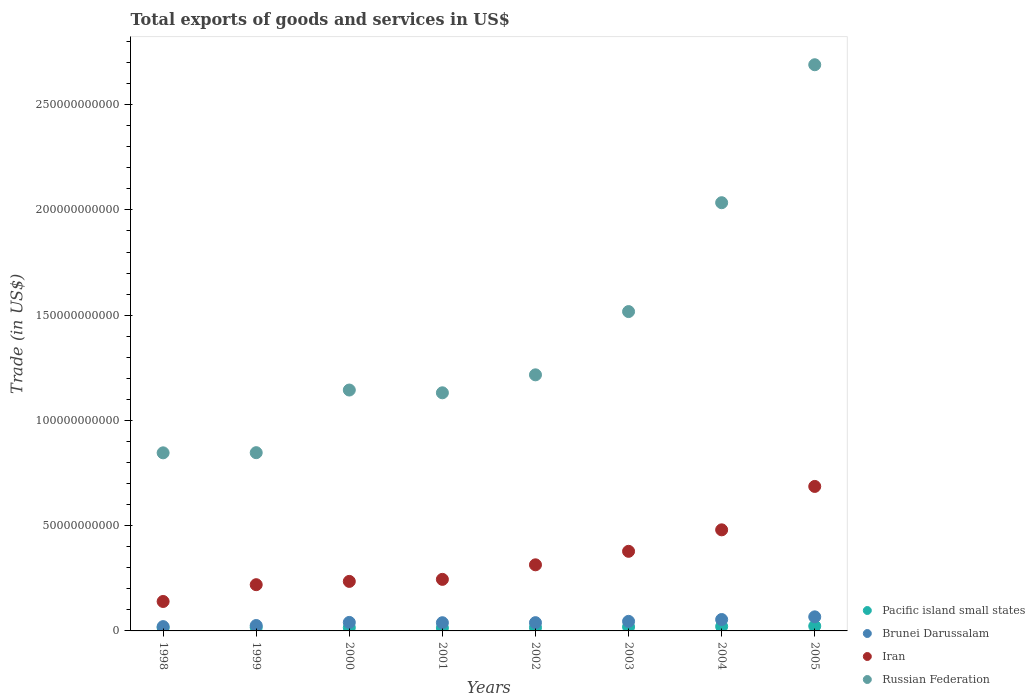How many different coloured dotlines are there?
Give a very brief answer. 4. Is the number of dotlines equal to the number of legend labels?
Offer a terse response. Yes. What is the total exports of goods and services in Russian Federation in 2004?
Give a very brief answer. 2.03e+11. Across all years, what is the maximum total exports of goods and services in Brunei Darussalam?
Provide a short and direct response. 6.69e+09. Across all years, what is the minimum total exports of goods and services in Brunei Darussalam?
Offer a very short reply. 2.04e+09. In which year was the total exports of goods and services in Iran maximum?
Provide a succinct answer. 2005. In which year was the total exports of goods and services in Iran minimum?
Provide a succinct answer. 1998. What is the total total exports of goods and services in Pacific island small states in the graph?
Ensure brevity in your answer.  1.40e+1. What is the difference between the total exports of goods and services in Brunei Darussalam in 1998 and that in 2003?
Keep it short and to the point. -2.50e+09. What is the difference between the total exports of goods and services in Brunei Darussalam in 2002 and the total exports of goods and services in Pacific island small states in 1999?
Give a very brief answer. 2.26e+09. What is the average total exports of goods and services in Russian Federation per year?
Make the answer very short. 1.43e+11. In the year 2000, what is the difference between the total exports of goods and services in Pacific island small states and total exports of goods and services in Russian Federation?
Offer a terse response. -1.13e+11. In how many years, is the total exports of goods and services in Pacific island small states greater than 120000000000 US$?
Provide a succinct answer. 0. What is the ratio of the total exports of goods and services in Russian Federation in 2001 to that in 2005?
Give a very brief answer. 0.42. What is the difference between the highest and the second highest total exports of goods and services in Russian Federation?
Your response must be concise. 6.55e+1. What is the difference between the highest and the lowest total exports of goods and services in Iran?
Provide a succinct answer. 5.46e+1. In how many years, is the total exports of goods and services in Iran greater than the average total exports of goods and services in Iran taken over all years?
Ensure brevity in your answer.  3. Is the sum of the total exports of goods and services in Brunei Darussalam in 1998 and 2002 greater than the maximum total exports of goods and services in Iran across all years?
Provide a succinct answer. No. Is it the case that in every year, the sum of the total exports of goods and services in Russian Federation and total exports of goods and services in Iran  is greater than the sum of total exports of goods and services in Pacific island small states and total exports of goods and services in Brunei Darussalam?
Make the answer very short. No. Is it the case that in every year, the sum of the total exports of goods and services in Pacific island small states and total exports of goods and services in Brunei Darussalam  is greater than the total exports of goods and services in Russian Federation?
Offer a terse response. No. How many dotlines are there?
Your answer should be very brief. 4. How many years are there in the graph?
Make the answer very short. 8. What is the difference between two consecutive major ticks on the Y-axis?
Keep it short and to the point. 5.00e+1. How are the legend labels stacked?
Your answer should be very brief. Vertical. What is the title of the graph?
Make the answer very short. Total exports of goods and services in US$. What is the label or title of the Y-axis?
Give a very brief answer. Trade (in US$). What is the Trade (in US$) of Pacific island small states in 1998?
Keep it short and to the point. 1.51e+09. What is the Trade (in US$) of Brunei Darussalam in 1998?
Keep it short and to the point. 2.04e+09. What is the Trade (in US$) in Iran in 1998?
Ensure brevity in your answer.  1.40e+1. What is the Trade (in US$) in Russian Federation in 1998?
Make the answer very short. 8.46e+1. What is the Trade (in US$) in Pacific island small states in 1999?
Your answer should be very brief. 1.67e+09. What is the Trade (in US$) in Brunei Darussalam in 1999?
Ensure brevity in your answer.  2.57e+09. What is the Trade (in US$) of Iran in 1999?
Ensure brevity in your answer.  2.20e+1. What is the Trade (in US$) in Russian Federation in 1999?
Your answer should be very brief. 8.47e+1. What is the Trade (in US$) in Pacific island small states in 2000?
Keep it short and to the point. 1.56e+09. What is the Trade (in US$) of Brunei Darussalam in 2000?
Offer a very short reply. 4.04e+09. What is the Trade (in US$) of Iran in 2000?
Ensure brevity in your answer.  2.35e+1. What is the Trade (in US$) of Russian Federation in 2000?
Offer a very short reply. 1.14e+11. What is the Trade (in US$) in Pacific island small states in 2001?
Offer a very short reply. 1.42e+09. What is the Trade (in US$) of Brunei Darussalam in 2001?
Offer a terse response. 3.89e+09. What is the Trade (in US$) in Iran in 2001?
Make the answer very short. 2.45e+1. What is the Trade (in US$) in Russian Federation in 2001?
Give a very brief answer. 1.13e+11. What is the Trade (in US$) of Pacific island small states in 2002?
Your response must be concise. 1.59e+09. What is the Trade (in US$) in Brunei Darussalam in 2002?
Your answer should be very brief. 3.92e+09. What is the Trade (in US$) of Iran in 2002?
Ensure brevity in your answer.  3.14e+1. What is the Trade (in US$) of Russian Federation in 2002?
Your answer should be compact. 1.22e+11. What is the Trade (in US$) of Pacific island small states in 2003?
Make the answer very short. 1.91e+09. What is the Trade (in US$) in Brunei Darussalam in 2003?
Ensure brevity in your answer.  4.54e+09. What is the Trade (in US$) of Iran in 2003?
Offer a very short reply. 3.78e+1. What is the Trade (in US$) in Russian Federation in 2003?
Your answer should be very brief. 1.52e+11. What is the Trade (in US$) of Pacific island small states in 2004?
Keep it short and to the point. 2.09e+09. What is the Trade (in US$) in Brunei Darussalam in 2004?
Provide a succinct answer. 5.42e+09. What is the Trade (in US$) of Iran in 2004?
Your answer should be very brief. 4.80e+1. What is the Trade (in US$) of Russian Federation in 2004?
Provide a succinct answer. 2.03e+11. What is the Trade (in US$) of Pacific island small states in 2005?
Your answer should be compact. 2.29e+09. What is the Trade (in US$) in Brunei Darussalam in 2005?
Your answer should be compact. 6.69e+09. What is the Trade (in US$) in Iran in 2005?
Keep it short and to the point. 6.86e+1. What is the Trade (in US$) of Russian Federation in 2005?
Offer a very short reply. 2.69e+11. Across all years, what is the maximum Trade (in US$) in Pacific island small states?
Offer a terse response. 2.29e+09. Across all years, what is the maximum Trade (in US$) in Brunei Darussalam?
Your answer should be very brief. 6.69e+09. Across all years, what is the maximum Trade (in US$) of Iran?
Make the answer very short. 6.86e+1. Across all years, what is the maximum Trade (in US$) of Russian Federation?
Give a very brief answer. 2.69e+11. Across all years, what is the minimum Trade (in US$) of Pacific island small states?
Your response must be concise. 1.42e+09. Across all years, what is the minimum Trade (in US$) of Brunei Darussalam?
Your answer should be very brief. 2.04e+09. Across all years, what is the minimum Trade (in US$) in Iran?
Provide a succinct answer. 1.40e+1. Across all years, what is the minimum Trade (in US$) in Russian Federation?
Give a very brief answer. 8.46e+1. What is the total Trade (in US$) in Pacific island small states in the graph?
Your answer should be compact. 1.40e+1. What is the total Trade (in US$) of Brunei Darussalam in the graph?
Provide a short and direct response. 3.31e+1. What is the total Trade (in US$) of Iran in the graph?
Give a very brief answer. 2.70e+11. What is the total Trade (in US$) of Russian Federation in the graph?
Provide a short and direct response. 1.14e+12. What is the difference between the Trade (in US$) in Pacific island small states in 1998 and that in 1999?
Offer a terse response. -1.59e+08. What is the difference between the Trade (in US$) of Brunei Darussalam in 1998 and that in 1999?
Offer a terse response. -5.23e+08. What is the difference between the Trade (in US$) in Iran in 1998 and that in 1999?
Keep it short and to the point. -7.98e+09. What is the difference between the Trade (in US$) in Russian Federation in 1998 and that in 1999?
Ensure brevity in your answer.  -7.54e+07. What is the difference between the Trade (in US$) in Pacific island small states in 1998 and that in 2000?
Your answer should be very brief. -5.57e+07. What is the difference between the Trade (in US$) in Brunei Darussalam in 1998 and that in 2000?
Your response must be concise. -2.00e+09. What is the difference between the Trade (in US$) in Iran in 1998 and that in 2000?
Give a very brief answer. -9.54e+09. What is the difference between the Trade (in US$) of Russian Federation in 1998 and that in 2000?
Give a very brief answer. -2.98e+1. What is the difference between the Trade (in US$) in Pacific island small states in 1998 and that in 2001?
Provide a succinct answer. 8.77e+07. What is the difference between the Trade (in US$) of Brunei Darussalam in 1998 and that in 2001?
Provide a succinct answer. -1.85e+09. What is the difference between the Trade (in US$) of Iran in 1998 and that in 2001?
Your answer should be compact. -1.05e+1. What is the difference between the Trade (in US$) in Russian Federation in 1998 and that in 2001?
Offer a very short reply. -2.85e+1. What is the difference between the Trade (in US$) in Pacific island small states in 1998 and that in 2002?
Make the answer very short. -8.04e+07. What is the difference between the Trade (in US$) of Brunei Darussalam in 1998 and that in 2002?
Offer a very short reply. -1.88e+09. What is the difference between the Trade (in US$) in Iran in 1998 and that in 2002?
Your answer should be compact. -1.74e+1. What is the difference between the Trade (in US$) of Russian Federation in 1998 and that in 2002?
Your response must be concise. -3.71e+1. What is the difference between the Trade (in US$) of Pacific island small states in 1998 and that in 2003?
Make the answer very short. -3.99e+08. What is the difference between the Trade (in US$) of Brunei Darussalam in 1998 and that in 2003?
Offer a very short reply. -2.50e+09. What is the difference between the Trade (in US$) of Iran in 1998 and that in 2003?
Make the answer very short. -2.38e+1. What is the difference between the Trade (in US$) in Russian Federation in 1998 and that in 2003?
Offer a terse response. -6.71e+1. What is the difference between the Trade (in US$) of Pacific island small states in 1998 and that in 2004?
Your response must be concise. -5.82e+08. What is the difference between the Trade (in US$) in Brunei Darussalam in 1998 and that in 2004?
Ensure brevity in your answer.  -3.37e+09. What is the difference between the Trade (in US$) of Iran in 1998 and that in 2004?
Offer a terse response. -3.40e+1. What is the difference between the Trade (in US$) in Russian Federation in 1998 and that in 2004?
Give a very brief answer. -1.19e+11. What is the difference between the Trade (in US$) in Pacific island small states in 1998 and that in 2005?
Make the answer very short. -7.88e+08. What is the difference between the Trade (in US$) in Brunei Darussalam in 1998 and that in 2005?
Offer a very short reply. -4.64e+09. What is the difference between the Trade (in US$) of Iran in 1998 and that in 2005?
Offer a very short reply. -5.46e+1. What is the difference between the Trade (in US$) in Russian Federation in 1998 and that in 2005?
Provide a succinct answer. -1.84e+11. What is the difference between the Trade (in US$) of Pacific island small states in 1999 and that in 2000?
Make the answer very short. 1.04e+08. What is the difference between the Trade (in US$) of Brunei Darussalam in 1999 and that in 2000?
Keep it short and to the point. -1.47e+09. What is the difference between the Trade (in US$) of Iran in 1999 and that in 2000?
Make the answer very short. -1.56e+09. What is the difference between the Trade (in US$) in Russian Federation in 1999 and that in 2000?
Offer a terse response. -2.98e+1. What is the difference between the Trade (in US$) in Pacific island small states in 1999 and that in 2001?
Your answer should be very brief. 2.47e+08. What is the difference between the Trade (in US$) in Brunei Darussalam in 1999 and that in 2001?
Ensure brevity in your answer.  -1.33e+09. What is the difference between the Trade (in US$) of Iran in 1999 and that in 2001?
Provide a succinct answer. -2.53e+09. What is the difference between the Trade (in US$) in Russian Federation in 1999 and that in 2001?
Offer a very short reply. -2.84e+1. What is the difference between the Trade (in US$) in Pacific island small states in 1999 and that in 2002?
Your response must be concise. 7.88e+07. What is the difference between the Trade (in US$) of Brunei Darussalam in 1999 and that in 2002?
Keep it short and to the point. -1.35e+09. What is the difference between the Trade (in US$) in Iran in 1999 and that in 2002?
Offer a terse response. -9.44e+09. What is the difference between the Trade (in US$) of Russian Federation in 1999 and that in 2002?
Make the answer very short. -3.70e+1. What is the difference between the Trade (in US$) of Pacific island small states in 1999 and that in 2003?
Your response must be concise. -2.40e+08. What is the difference between the Trade (in US$) in Brunei Darussalam in 1999 and that in 2003?
Offer a very short reply. -1.98e+09. What is the difference between the Trade (in US$) in Iran in 1999 and that in 2003?
Your response must be concise. -1.59e+1. What is the difference between the Trade (in US$) in Russian Federation in 1999 and that in 2003?
Keep it short and to the point. -6.70e+1. What is the difference between the Trade (in US$) of Pacific island small states in 1999 and that in 2004?
Give a very brief answer. -4.23e+08. What is the difference between the Trade (in US$) in Brunei Darussalam in 1999 and that in 2004?
Give a very brief answer. -2.85e+09. What is the difference between the Trade (in US$) in Iran in 1999 and that in 2004?
Provide a short and direct response. -2.61e+1. What is the difference between the Trade (in US$) of Russian Federation in 1999 and that in 2004?
Offer a terse response. -1.19e+11. What is the difference between the Trade (in US$) in Pacific island small states in 1999 and that in 2005?
Your response must be concise. -6.28e+08. What is the difference between the Trade (in US$) of Brunei Darussalam in 1999 and that in 2005?
Your answer should be very brief. -4.12e+09. What is the difference between the Trade (in US$) in Iran in 1999 and that in 2005?
Make the answer very short. -4.67e+1. What is the difference between the Trade (in US$) in Russian Federation in 1999 and that in 2005?
Your answer should be very brief. -1.84e+11. What is the difference between the Trade (in US$) in Pacific island small states in 2000 and that in 2001?
Your answer should be compact. 1.43e+08. What is the difference between the Trade (in US$) in Brunei Darussalam in 2000 and that in 2001?
Give a very brief answer. 1.48e+08. What is the difference between the Trade (in US$) in Iran in 2000 and that in 2001?
Make the answer very short. -9.66e+08. What is the difference between the Trade (in US$) in Russian Federation in 2000 and that in 2001?
Offer a very short reply. 1.31e+09. What is the difference between the Trade (in US$) in Pacific island small states in 2000 and that in 2002?
Your answer should be compact. -2.47e+07. What is the difference between the Trade (in US$) of Brunei Darussalam in 2000 and that in 2002?
Provide a short and direct response. 1.20e+08. What is the difference between the Trade (in US$) of Iran in 2000 and that in 2002?
Provide a succinct answer. -7.88e+09. What is the difference between the Trade (in US$) of Russian Federation in 2000 and that in 2002?
Keep it short and to the point. -7.22e+09. What is the difference between the Trade (in US$) of Pacific island small states in 2000 and that in 2003?
Ensure brevity in your answer.  -3.44e+08. What is the difference between the Trade (in US$) in Brunei Darussalam in 2000 and that in 2003?
Offer a terse response. -5.01e+08. What is the difference between the Trade (in US$) in Iran in 2000 and that in 2003?
Give a very brief answer. -1.43e+1. What is the difference between the Trade (in US$) in Russian Federation in 2000 and that in 2003?
Provide a short and direct response. -3.73e+1. What is the difference between the Trade (in US$) in Pacific island small states in 2000 and that in 2004?
Give a very brief answer. -5.27e+08. What is the difference between the Trade (in US$) in Brunei Darussalam in 2000 and that in 2004?
Keep it short and to the point. -1.37e+09. What is the difference between the Trade (in US$) of Iran in 2000 and that in 2004?
Make the answer very short. -2.45e+1. What is the difference between the Trade (in US$) of Russian Federation in 2000 and that in 2004?
Offer a terse response. -8.90e+1. What is the difference between the Trade (in US$) of Pacific island small states in 2000 and that in 2005?
Provide a short and direct response. -7.32e+08. What is the difference between the Trade (in US$) of Brunei Darussalam in 2000 and that in 2005?
Make the answer very short. -2.65e+09. What is the difference between the Trade (in US$) of Iran in 2000 and that in 2005?
Give a very brief answer. -4.51e+1. What is the difference between the Trade (in US$) of Russian Federation in 2000 and that in 2005?
Offer a terse response. -1.55e+11. What is the difference between the Trade (in US$) of Pacific island small states in 2001 and that in 2002?
Your response must be concise. -1.68e+08. What is the difference between the Trade (in US$) in Brunei Darussalam in 2001 and that in 2002?
Make the answer very short. -2.80e+07. What is the difference between the Trade (in US$) of Iran in 2001 and that in 2002?
Keep it short and to the point. -6.91e+09. What is the difference between the Trade (in US$) of Russian Federation in 2001 and that in 2002?
Offer a terse response. -8.53e+09. What is the difference between the Trade (in US$) in Pacific island small states in 2001 and that in 2003?
Offer a very short reply. -4.87e+08. What is the difference between the Trade (in US$) in Brunei Darussalam in 2001 and that in 2003?
Give a very brief answer. -6.49e+08. What is the difference between the Trade (in US$) in Iran in 2001 and that in 2003?
Give a very brief answer. -1.33e+1. What is the difference between the Trade (in US$) in Russian Federation in 2001 and that in 2003?
Your answer should be compact. -3.86e+1. What is the difference between the Trade (in US$) of Pacific island small states in 2001 and that in 2004?
Your answer should be compact. -6.70e+08. What is the difference between the Trade (in US$) of Brunei Darussalam in 2001 and that in 2004?
Provide a succinct answer. -1.52e+09. What is the difference between the Trade (in US$) of Iran in 2001 and that in 2004?
Ensure brevity in your answer.  -2.35e+1. What is the difference between the Trade (in US$) in Russian Federation in 2001 and that in 2004?
Make the answer very short. -9.03e+1. What is the difference between the Trade (in US$) of Pacific island small states in 2001 and that in 2005?
Give a very brief answer. -8.75e+08. What is the difference between the Trade (in US$) in Brunei Darussalam in 2001 and that in 2005?
Offer a very short reply. -2.79e+09. What is the difference between the Trade (in US$) in Iran in 2001 and that in 2005?
Your response must be concise. -4.41e+1. What is the difference between the Trade (in US$) of Russian Federation in 2001 and that in 2005?
Your answer should be compact. -1.56e+11. What is the difference between the Trade (in US$) of Pacific island small states in 2002 and that in 2003?
Keep it short and to the point. -3.19e+08. What is the difference between the Trade (in US$) of Brunei Darussalam in 2002 and that in 2003?
Keep it short and to the point. -6.21e+08. What is the difference between the Trade (in US$) of Iran in 2002 and that in 2003?
Offer a very short reply. -6.41e+09. What is the difference between the Trade (in US$) of Russian Federation in 2002 and that in 2003?
Keep it short and to the point. -3.00e+1. What is the difference between the Trade (in US$) in Pacific island small states in 2002 and that in 2004?
Offer a very short reply. -5.02e+08. What is the difference between the Trade (in US$) of Brunei Darussalam in 2002 and that in 2004?
Make the answer very short. -1.49e+09. What is the difference between the Trade (in US$) in Iran in 2002 and that in 2004?
Ensure brevity in your answer.  -1.66e+1. What is the difference between the Trade (in US$) in Russian Federation in 2002 and that in 2004?
Your answer should be very brief. -8.18e+1. What is the difference between the Trade (in US$) in Pacific island small states in 2002 and that in 2005?
Give a very brief answer. -7.07e+08. What is the difference between the Trade (in US$) of Brunei Darussalam in 2002 and that in 2005?
Your answer should be compact. -2.77e+09. What is the difference between the Trade (in US$) in Iran in 2002 and that in 2005?
Ensure brevity in your answer.  -3.72e+1. What is the difference between the Trade (in US$) of Russian Federation in 2002 and that in 2005?
Offer a very short reply. -1.47e+11. What is the difference between the Trade (in US$) of Pacific island small states in 2003 and that in 2004?
Your answer should be compact. -1.83e+08. What is the difference between the Trade (in US$) in Brunei Darussalam in 2003 and that in 2004?
Your answer should be very brief. -8.73e+08. What is the difference between the Trade (in US$) in Iran in 2003 and that in 2004?
Make the answer very short. -1.02e+1. What is the difference between the Trade (in US$) of Russian Federation in 2003 and that in 2004?
Give a very brief answer. -5.17e+1. What is the difference between the Trade (in US$) of Pacific island small states in 2003 and that in 2005?
Your answer should be compact. -3.88e+08. What is the difference between the Trade (in US$) in Brunei Darussalam in 2003 and that in 2005?
Your response must be concise. -2.14e+09. What is the difference between the Trade (in US$) of Iran in 2003 and that in 2005?
Offer a very short reply. -3.08e+1. What is the difference between the Trade (in US$) of Russian Federation in 2003 and that in 2005?
Make the answer very short. -1.17e+11. What is the difference between the Trade (in US$) of Pacific island small states in 2004 and that in 2005?
Keep it short and to the point. -2.05e+08. What is the difference between the Trade (in US$) in Brunei Darussalam in 2004 and that in 2005?
Your answer should be compact. -1.27e+09. What is the difference between the Trade (in US$) of Iran in 2004 and that in 2005?
Offer a very short reply. -2.06e+1. What is the difference between the Trade (in US$) in Russian Federation in 2004 and that in 2005?
Your answer should be compact. -6.55e+1. What is the difference between the Trade (in US$) in Pacific island small states in 1998 and the Trade (in US$) in Brunei Darussalam in 1999?
Your answer should be compact. -1.06e+09. What is the difference between the Trade (in US$) of Pacific island small states in 1998 and the Trade (in US$) of Iran in 1999?
Give a very brief answer. -2.05e+1. What is the difference between the Trade (in US$) of Pacific island small states in 1998 and the Trade (in US$) of Russian Federation in 1999?
Offer a terse response. -8.32e+1. What is the difference between the Trade (in US$) in Brunei Darussalam in 1998 and the Trade (in US$) in Iran in 1999?
Provide a short and direct response. -1.99e+1. What is the difference between the Trade (in US$) in Brunei Darussalam in 1998 and the Trade (in US$) in Russian Federation in 1999?
Make the answer very short. -8.26e+1. What is the difference between the Trade (in US$) in Iran in 1998 and the Trade (in US$) in Russian Federation in 1999?
Make the answer very short. -7.07e+1. What is the difference between the Trade (in US$) in Pacific island small states in 1998 and the Trade (in US$) in Brunei Darussalam in 2000?
Ensure brevity in your answer.  -2.53e+09. What is the difference between the Trade (in US$) of Pacific island small states in 1998 and the Trade (in US$) of Iran in 2000?
Ensure brevity in your answer.  -2.20e+1. What is the difference between the Trade (in US$) of Pacific island small states in 1998 and the Trade (in US$) of Russian Federation in 2000?
Offer a very short reply. -1.13e+11. What is the difference between the Trade (in US$) of Brunei Darussalam in 1998 and the Trade (in US$) of Iran in 2000?
Your answer should be compact. -2.15e+1. What is the difference between the Trade (in US$) of Brunei Darussalam in 1998 and the Trade (in US$) of Russian Federation in 2000?
Offer a terse response. -1.12e+11. What is the difference between the Trade (in US$) in Iran in 1998 and the Trade (in US$) in Russian Federation in 2000?
Provide a succinct answer. -1.00e+11. What is the difference between the Trade (in US$) in Pacific island small states in 1998 and the Trade (in US$) in Brunei Darussalam in 2001?
Your answer should be compact. -2.39e+09. What is the difference between the Trade (in US$) in Pacific island small states in 1998 and the Trade (in US$) in Iran in 2001?
Offer a terse response. -2.30e+1. What is the difference between the Trade (in US$) in Pacific island small states in 1998 and the Trade (in US$) in Russian Federation in 2001?
Your response must be concise. -1.12e+11. What is the difference between the Trade (in US$) in Brunei Darussalam in 1998 and the Trade (in US$) in Iran in 2001?
Make the answer very short. -2.24e+1. What is the difference between the Trade (in US$) in Brunei Darussalam in 1998 and the Trade (in US$) in Russian Federation in 2001?
Your answer should be very brief. -1.11e+11. What is the difference between the Trade (in US$) in Iran in 1998 and the Trade (in US$) in Russian Federation in 2001?
Offer a very short reply. -9.91e+1. What is the difference between the Trade (in US$) in Pacific island small states in 1998 and the Trade (in US$) in Brunei Darussalam in 2002?
Offer a very short reply. -2.42e+09. What is the difference between the Trade (in US$) of Pacific island small states in 1998 and the Trade (in US$) of Iran in 2002?
Provide a short and direct response. -2.99e+1. What is the difference between the Trade (in US$) in Pacific island small states in 1998 and the Trade (in US$) in Russian Federation in 2002?
Make the answer very short. -1.20e+11. What is the difference between the Trade (in US$) of Brunei Darussalam in 1998 and the Trade (in US$) of Iran in 2002?
Make the answer very short. -2.94e+1. What is the difference between the Trade (in US$) in Brunei Darussalam in 1998 and the Trade (in US$) in Russian Federation in 2002?
Ensure brevity in your answer.  -1.20e+11. What is the difference between the Trade (in US$) in Iran in 1998 and the Trade (in US$) in Russian Federation in 2002?
Your response must be concise. -1.08e+11. What is the difference between the Trade (in US$) in Pacific island small states in 1998 and the Trade (in US$) in Brunei Darussalam in 2003?
Your answer should be very brief. -3.04e+09. What is the difference between the Trade (in US$) of Pacific island small states in 1998 and the Trade (in US$) of Iran in 2003?
Make the answer very short. -3.63e+1. What is the difference between the Trade (in US$) of Pacific island small states in 1998 and the Trade (in US$) of Russian Federation in 2003?
Give a very brief answer. -1.50e+11. What is the difference between the Trade (in US$) in Brunei Darussalam in 1998 and the Trade (in US$) in Iran in 2003?
Give a very brief answer. -3.58e+1. What is the difference between the Trade (in US$) in Brunei Darussalam in 1998 and the Trade (in US$) in Russian Federation in 2003?
Your answer should be compact. -1.50e+11. What is the difference between the Trade (in US$) in Iran in 1998 and the Trade (in US$) in Russian Federation in 2003?
Give a very brief answer. -1.38e+11. What is the difference between the Trade (in US$) of Pacific island small states in 1998 and the Trade (in US$) of Brunei Darussalam in 2004?
Offer a very short reply. -3.91e+09. What is the difference between the Trade (in US$) in Pacific island small states in 1998 and the Trade (in US$) in Iran in 2004?
Provide a short and direct response. -4.65e+1. What is the difference between the Trade (in US$) of Pacific island small states in 1998 and the Trade (in US$) of Russian Federation in 2004?
Ensure brevity in your answer.  -2.02e+11. What is the difference between the Trade (in US$) of Brunei Darussalam in 1998 and the Trade (in US$) of Iran in 2004?
Offer a very short reply. -4.60e+1. What is the difference between the Trade (in US$) of Brunei Darussalam in 1998 and the Trade (in US$) of Russian Federation in 2004?
Your answer should be very brief. -2.01e+11. What is the difference between the Trade (in US$) of Iran in 1998 and the Trade (in US$) of Russian Federation in 2004?
Keep it short and to the point. -1.89e+11. What is the difference between the Trade (in US$) in Pacific island small states in 1998 and the Trade (in US$) in Brunei Darussalam in 2005?
Provide a succinct answer. -5.18e+09. What is the difference between the Trade (in US$) of Pacific island small states in 1998 and the Trade (in US$) of Iran in 2005?
Your response must be concise. -6.71e+1. What is the difference between the Trade (in US$) of Pacific island small states in 1998 and the Trade (in US$) of Russian Federation in 2005?
Provide a succinct answer. -2.67e+11. What is the difference between the Trade (in US$) in Brunei Darussalam in 1998 and the Trade (in US$) in Iran in 2005?
Your answer should be compact. -6.66e+1. What is the difference between the Trade (in US$) of Brunei Darussalam in 1998 and the Trade (in US$) of Russian Federation in 2005?
Make the answer very short. -2.67e+11. What is the difference between the Trade (in US$) of Iran in 1998 and the Trade (in US$) of Russian Federation in 2005?
Provide a succinct answer. -2.55e+11. What is the difference between the Trade (in US$) in Pacific island small states in 1999 and the Trade (in US$) in Brunei Darussalam in 2000?
Give a very brief answer. -2.38e+09. What is the difference between the Trade (in US$) in Pacific island small states in 1999 and the Trade (in US$) in Iran in 2000?
Your answer should be compact. -2.19e+1. What is the difference between the Trade (in US$) in Pacific island small states in 1999 and the Trade (in US$) in Russian Federation in 2000?
Keep it short and to the point. -1.13e+11. What is the difference between the Trade (in US$) in Brunei Darussalam in 1999 and the Trade (in US$) in Iran in 2000?
Keep it short and to the point. -2.10e+1. What is the difference between the Trade (in US$) in Brunei Darussalam in 1999 and the Trade (in US$) in Russian Federation in 2000?
Give a very brief answer. -1.12e+11. What is the difference between the Trade (in US$) in Iran in 1999 and the Trade (in US$) in Russian Federation in 2000?
Keep it short and to the point. -9.25e+1. What is the difference between the Trade (in US$) in Pacific island small states in 1999 and the Trade (in US$) in Brunei Darussalam in 2001?
Offer a terse response. -2.23e+09. What is the difference between the Trade (in US$) of Pacific island small states in 1999 and the Trade (in US$) of Iran in 2001?
Provide a succinct answer. -2.28e+1. What is the difference between the Trade (in US$) in Pacific island small states in 1999 and the Trade (in US$) in Russian Federation in 2001?
Offer a very short reply. -1.11e+11. What is the difference between the Trade (in US$) of Brunei Darussalam in 1999 and the Trade (in US$) of Iran in 2001?
Provide a succinct answer. -2.19e+1. What is the difference between the Trade (in US$) of Brunei Darussalam in 1999 and the Trade (in US$) of Russian Federation in 2001?
Provide a short and direct response. -1.11e+11. What is the difference between the Trade (in US$) in Iran in 1999 and the Trade (in US$) in Russian Federation in 2001?
Make the answer very short. -9.12e+1. What is the difference between the Trade (in US$) in Pacific island small states in 1999 and the Trade (in US$) in Brunei Darussalam in 2002?
Provide a short and direct response. -2.26e+09. What is the difference between the Trade (in US$) of Pacific island small states in 1999 and the Trade (in US$) of Iran in 2002?
Keep it short and to the point. -2.97e+1. What is the difference between the Trade (in US$) of Pacific island small states in 1999 and the Trade (in US$) of Russian Federation in 2002?
Your answer should be compact. -1.20e+11. What is the difference between the Trade (in US$) in Brunei Darussalam in 1999 and the Trade (in US$) in Iran in 2002?
Keep it short and to the point. -2.88e+1. What is the difference between the Trade (in US$) of Brunei Darussalam in 1999 and the Trade (in US$) of Russian Federation in 2002?
Your answer should be compact. -1.19e+11. What is the difference between the Trade (in US$) of Iran in 1999 and the Trade (in US$) of Russian Federation in 2002?
Provide a short and direct response. -9.97e+1. What is the difference between the Trade (in US$) in Pacific island small states in 1999 and the Trade (in US$) in Brunei Darussalam in 2003?
Offer a terse response. -2.88e+09. What is the difference between the Trade (in US$) of Pacific island small states in 1999 and the Trade (in US$) of Iran in 2003?
Offer a terse response. -3.61e+1. What is the difference between the Trade (in US$) in Pacific island small states in 1999 and the Trade (in US$) in Russian Federation in 2003?
Ensure brevity in your answer.  -1.50e+11. What is the difference between the Trade (in US$) in Brunei Darussalam in 1999 and the Trade (in US$) in Iran in 2003?
Your answer should be compact. -3.52e+1. What is the difference between the Trade (in US$) in Brunei Darussalam in 1999 and the Trade (in US$) in Russian Federation in 2003?
Provide a short and direct response. -1.49e+11. What is the difference between the Trade (in US$) of Iran in 1999 and the Trade (in US$) of Russian Federation in 2003?
Ensure brevity in your answer.  -1.30e+11. What is the difference between the Trade (in US$) in Pacific island small states in 1999 and the Trade (in US$) in Brunei Darussalam in 2004?
Your response must be concise. -3.75e+09. What is the difference between the Trade (in US$) in Pacific island small states in 1999 and the Trade (in US$) in Iran in 2004?
Provide a succinct answer. -4.64e+1. What is the difference between the Trade (in US$) of Pacific island small states in 1999 and the Trade (in US$) of Russian Federation in 2004?
Give a very brief answer. -2.02e+11. What is the difference between the Trade (in US$) in Brunei Darussalam in 1999 and the Trade (in US$) in Iran in 2004?
Offer a terse response. -4.55e+1. What is the difference between the Trade (in US$) of Brunei Darussalam in 1999 and the Trade (in US$) of Russian Federation in 2004?
Offer a terse response. -2.01e+11. What is the difference between the Trade (in US$) of Iran in 1999 and the Trade (in US$) of Russian Federation in 2004?
Offer a terse response. -1.81e+11. What is the difference between the Trade (in US$) of Pacific island small states in 1999 and the Trade (in US$) of Brunei Darussalam in 2005?
Your answer should be compact. -5.02e+09. What is the difference between the Trade (in US$) of Pacific island small states in 1999 and the Trade (in US$) of Iran in 2005?
Keep it short and to the point. -6.70e+1. What is the difference between the Trade (in US$) of Pacific island small states in 1999 and the Trade (in US$) of Russian Federation in 2005?
Your response must be concise. -2.67e+11. What is the difference between the Trade (in US$) of Brunei Darussalam in 1999 and the Trade (in US$) of Iran in 2005?
Provide a succinct answer. -6.61e+1. What is the difference between the Trade (in US$) in Brunei Darussalam in 1999 and the Trade (in US$) in Russian Federation in 2005?
Give a very brief answer. -2.66e+11. What is the difference between the Trade (in US$) in Iran in 1999 and the Trade (in US$) in Russian Federation in 2005?
Keep it short and to the point. -2.47e+11. What is the difference between the Trade (in US$) in Pacific island small states in 2000 and the Trade (in US$) in Brunei Darussalam in 2001?
Your answer should be compact. -2.33e+09. What is the difference between the Trade (in US$) of Pacific island small states in 2000 and the Trade (in US$) of Iran in 2001?
Your response must be concise. -2.29e+1. What is the difference between the Trade (in US$) of Pacific island small states in 2000 and the Trade (in US$) of Russian Federation in 2001?
Keep it short and to the point. -1.12e+11. What is the difference between the Trade (in US$) of Brunei Darussalam in 2000 and the Trade (in US$) of Iran in 2001?
Make the answer very short. -2.04e+1. What is the difference between the Trade (in US$) in Brunei Darussalam in 2000 and the Trade (in US$) in Russian Federation in 2001?
Ensure brevity in your answer.  -1.09e+11. What is the difference between the Trade (in US$) of Iran in 2000 and the Trade (in US$) of Russian Federation in 2001?
Make the answer very short. -8.96e+1. What is the difference between the Trade (in US$) of Pacific island small states in 2000 and the Trade (in US$) of Brunei Darussalam in 2002?
Your answer should be very brief. -2.36e+09. What is the difference between the Trade (in US$) of Pacific island small states in 2000 and the Trade (in US$) of Iran in 2002?
Offer a very short reply. -2.98e+1. What is the difference between the Trade (in US$) of Pacific island small states in 2000 and the Trade (in US$) of Russian Federation in 2002?
Your answer should be very brief. -1.20e+11. What is the difference between the Trade (in US$) in Brunei Darussalam in 2000 and the Trade (in US$) in Iran in 2002?
Provide a short and direct response. -2.74e+1. What is the difference between the Trade (in US$) of Brunei Darussalam in 2000 and the Trade (in US$) of Russian Federation in 2002?
Provide a short and direct response. -1.18e+11. What is the difference between the Trade (in US$) in Iran in 2000 and the Trade (in US$) in Russian Federation in 2002?
Your response must be concise. -9.81e+1. What is the difference between the Trade (in US$) of Pacific island small states in 2000 and the Trade (in US$) of Brunei Darussalam in 2003?
Offer a very short reply. -2.98e+09. What is the difference between the Trade (in US$) of Pacific island small states in 2000 and the Trade (in US$) of Iran in 2003?
Ensure brevity in your answer.  -3.63e+1. What is the difference between the Trade (in US$) in Pacific island small states in 2000 and the Trade (in US$) in Russian Federation in 2003?
Make the answer very short. -1.50e+11. What is the difference between the Trade (in US$) of Brunei Darussalam in 2000 and the Trade (in US$) of Iran in 2003?
Offer a terse response. -3.38e+1. What is the difference between the Trade (in US$) of Brunei Darussalam in 2000 and the Trade (in US$) of Russian Federation in 2003?
Your response must be concise. -1.48e+11. What is the difference between the Trade (in US$) in Iran in 2000 and the Trade (in US$) in Russian Federation in 2003?
Give a very brief answer. -1.28e+11. What is the difference between the Trade (in US$) in Pacific island small states in 2000 and the Trade (in US$) in Brunei Darussalam in 2004?
Offer a very short reply. -3.85e+09. What is the difference between the Trade (in US$) in Pacific island small states in 2000 and the Trade (in US$) in Iran in 2004?
Keep it short and to the point. -4.65e+1. What is the difference between the Trade (in US$) in Pacific island small states in 2000 and the Trade (in US$) in Russian Federation in 2004?
Make the answer very short. -2.02e+11. What is the difference between the Trade (in US$) in Brunei Darussalam in 2000 and the Trade (in US$) in Iran in 2004?
Offer a very short reply. -4.40e+1. What is the difference between the Trade (in US$) in Brunei Darussalam in 2000 and the Trade (in US$) in Russian Federation in 2004?
Your answer should be compact. -1.99e+11. What is the difference between the Trade (in US$) in Iran in 2000 and the Trade (in US$) in Russian Federation in 2004?
Give a very brief answer. -1.80e+11. What is the difference between the Trade (in US$) in Pacific island small states in 2000 and the Trade (in US$) in Brunei Darussalam in 2005?
Give a very brief answer. -5.13e+09. What is the difference between the Trade (in US$) in Pacific island small states in 2000 and the Trade (in US$) in Iran in 2005?
Your answer should be compact. -6.71e+1. What is the difference between the Trade (in US$) in Pacific island small states in 2000 and the Trade (in US$) in Russian Federation in 2005?
Offer a very short reply. -2.67e+11. What is the difference between the Trade (in US$) in Brunei Darussalam in 2000 and the Trade (in US$) in Iran in 2005?
Make the answer very short. -6.46e+1. What is the difference between the Trade (in US$) of Brunei Darussalam in 2000 and the Trade (in US$) of Russian Federation in 2005?
Offer a terse response. -2.65e+11. What is the difference between the Trade (in US$) of Iran in 2000 and the Trade (in US$) of Russian Federation in 2005?
Your answer should be compact. -2.45e+11. What is the difference between the Trade (in US$) of Pacific island small states in 2001 and the Trade (in US$) of Brunei Darussalam in 2002?
Offer a terse response. -2.50e+09. What is the difference between the Trade (in US$) of Pacific island small states in 2001 and the Trade (in US$) of Iran in 2002?
Keep it short and to the point. -3.00e+1. What is the difference between the Trade (in US$) of Pacific island small states in 2001 and the Trade (in US$) of Russian Federation in 2002?
Give a very brief answer. -1.20e+11. What is the difference between the Trade (in US$) in Brunei Darussalam in 2001 and the Trade (in US$) in Iran in 2002?
Ensure brevity in your answer.  -2.75e+1. What is the difference between the Trade (in US$) in Brunei Darussalam in 2001 and the Trade (in US$) in Russian Federation in 2002?
Your answer should be compact. -1.18e+11. What is the difference between the Trade (in US$) of Iran in 2001 and the Trade (in US$) of Russian Federation in 2002?
Keep it short and to the point. -9.72e+1. What is the difference between the Trade (in US$) of Pacific island small states in 2001 and the Trade (in US$) of Brunei Darussalam in 2003?
Give a very brief answer. -3.12e+09. What is the difference between the Trade (in US$) in Pacific island small states in 2001 and the Trade (in US$) in Iran in 2003?
Give a very brief answer. -3.64e+1. What is the difference between the Trade (in US$) of Pacific island small states in 2001 and the Trade (in US$) of Russian Federation in 2003?
Your answer should be compact. -1.50e+11. What is the difference between the Trade (in US$) of Brunei Darussalam in 2001 and the Trade (in US$) of Iran in 2003?
Make the answer very short. -3.39e+1. What is the difference between the Trade (in US$) of Brunei Darussalam in 2001 and the Trade (in US$) of Russian Federation in 2003?
Give a very brief answer. -1.48e+11. What is the difference between the Trade (in US$) of Iran in 2001 and the Trade (in US$) of Russian Federation in 2003?
Offer a terse response. -1.27e+11. What is the difference between the Trade (in US$) of Pacific island small states in 2001 and the Trade (in US$) of Brunei Darussalam in 2004?
Make the answer very short. -4.00e+09. What is the difference between the Trade (in US$) of Pacific island small states in 2001 and the Trade (in US$) of Iran in 2004?
Provide a short and direct response. -4.66e+1. What is the difference between the Trade (in US$) of Pacific island small states in 2001 and the Trade (in US$) of Russian Federation in 2004?
Provide a succinct answer. -2.02e+11. What is the difference between the Trade (in US$) in Brunei Darussalam in 2001 and the Trade (in US$) in Iran in 2004?
Make the answer very short. -4.41e+1. What is the difference between the Trade (in US$) of Brunei Darussalam in 2001 and the Trade (in US$) of Russian Federation in 2004?
Ensure brevity in your answer.  -2.00e+11. What is the difference between the Trade (in US$) of Iran in 2001 and the Trade (in US$) of Russian Federation in 2004?
Ensure brevity in your answer.  -1.79e+11. What is the difference between the Trade (in US$) in Pacific island small states in 2001 and the Trade (in US$) in Brunei Darussalam in 2005?
Keep it short and to the point. -5.27e+09. What is the difference between the Trade (in US$) of Pacific island small states in 2001 and the Trade (in US$) of Iran in 2005?
Ensure brevity in your answer.  -6.72e+1. What is the difference between the Trade (in US$) in Pacific island small states in 2001 and the Trade (in US$) in Russian Federation in 2005?
Keep it short and to the point. -2.68e+11. What is the difference between the Trade (in US$) of Brunei Darussalam in 2001 and the Trade (in US$) of Iran in 2005?
Keep it short and to the point. -6.47e+1. What is the difference between the Trade (in US$) in Brunei Darussalam in 2001 and the Trade (in US$) in Russian Federation in 2005?
Keep it short and to the point. -2.65e+11. What is the difference between the Trade (in US$) in Iran in 2001 and the Trade (in US$) in Russian Federation in 2005?
Offer a terse response. -2.44e+11. What is the difference between the Trade (in US$) of Pacific island small states in 2002 and the Trade (in US$) of Brunei Darussalam in 2003?
Your response must be concise. -2.96e+09. What is the difference between the Trade (in US$) of Pacific island small states in 2002 and the Trade (in US$) of Iran in 2003?
Provide a succinct answer. -3.62e+1. What is the difference between the Trade (in US$) of Pacific island small states in 2002 and the Trade (in US$) of Russian Federation in 2003?
Give a very brief answer. -1.50e+11. What is the difference between the Trade (in US$) of Brunei Darussalam in 2002 and the Trade (in US$) of Iran in 2003?
Your response must be concise. -3.39e+1. What is the difference between the Trade (in US$) in Brunei Darussalam in 2002 and the Trade (in US$) in Russian Federation in 2003?
Give a very brief answer. -1.48e+11. What is the difference between the Trade (in US$) of Iran in 2002 and the Trade (in US$) of Russian Federation in 2003?
Provide a short and direct response. -1.20e+11. What is the difference between the Trade (in US$) in Pacific island small states in 2002 and the Trade (in US$) in Brunei Darussalam in 2004?
Provide a short and direct response. -3.83e+09. What is the difference between the Trade (in US$) of Pacific island small states in 2002 and the Trade (in US$) of Iran in 2004?
Keep it short and to the point. -4.64e+1. What is the difference between the Trade (in US$) of Pacific island small states in 2002 and the Trade (in US$) of Russian Federation in 2004?
Make the answer very short. -2.02e+11. What is the difference between the Trade (in US$) in Brunei Darussalam in 2002 and the Trade (in US$) in Iran in 2004?
Offer a very short reply. -4.41e+1. What is the difference between the Trade (in US$) of Brunei Darussalam in 2002 and the Trade (in US$) of Russian Federation in 2004?
Your answer should be very brief. -1.99e+11. What is the difference between the Trade (in US$) of Iran in 2002 and the Trade (in US$) of Russian Federation in 2004?
Give a very brief answer. -1.72e+11. What is the difference between the Trade (in US$) of Pacific island small states in 2002 and the Trade (in US$) of Brunei Darussalam in 2005?
Give a very brief answer. -5.10e+09. What is the difference between the Trade (in US$) of Pacific island small states in 2002 and the Trade (in US$) of Iran in 2005?
Your answer should be compact. -6.70e+1. What is the difference between the Trade (in US$) in Pacific island small states in 2002 and the Trade (in US$) in Russian Federation in 2005?
Make the answer very short. -2.67e+11. What is the difference between the Trade (in US$) in Brunei Darussalam in 2002 and the Trade (in US$) in Iran in 2005?
Your answer should be very brief. -6.47e+1. What is the difference between the Trade (in US$) in Brunei Darussalam in 2002 and the Trade (in US$) in Russian Federation in 2005?
Your response must be concise. -2.65e+11. What is the difference between the Trade (in US$) of Iran in 2002 and the Trade (in US$) of Russian Federation in 2005?
Provide a short and direct response. -2.38e+11. What is the difference between the Trade (in US$) of Pacific island small states in 2003 and the Trade (in US$) of Brunei Darussalam in 2004?
Your answer should be very brief. -3.51e+09. What is the difference between the Trade (in US$) in Pacific island small states in 2003 and the Trade (in US$) in Iran in 2004?
Give a very brief answer. -4.61e+1. What is the difference between the Trade (in US$) in Pacific island small states in 2003 and the Trade (in US$) in Russian Federation in 2004?
Provide a short and direct response. -2.02e+11. What is the difference between the Trade (in US$) of Brunei Darussalam in 2003 and the Trade (in US$) of Iran in 2004?
Your answer should be very brief. -4.35e+1. What is the difference between the Trade (in US$) of Brunei Darussalam in 2003 and the Trade (in US$) of Russian Federation in 2004?
Give a very brief answer. -1.99e+11. What is the difference between the Trade (in US$) of Iran in 2003 and the Trade (in US$) of Russian Federation in 2004?
Your answer should be very brief. -1.66e+11. What is the difference between the Trade (in US$) of Pacific island small states in 2003 and the Trade (in US$) of Brunei Darussalam in 2005?
Your answer should be very brief. -4.78e+09. What is the difference between the Trade (in US$) in Pacific island small states in 2003 and the Trade (in US$) in Iran in 2005?
Your response must be concise. -6.67e+1. What is the difference between the Trade (in US$) in Pacific island small states in 2003 and the Trade (in US$) in Russian Federation in 2005?
Your response must be concise. -2.67e+11. What is the difference between the Trade (in US$) of Brunei Darussalam in 2003 and the Trade (in US$) of Iran in 2005?
Keep it short and to the point. -6.41e+1. What is the difference between the Trade (in US$) in Brunei Darussalam in 2003 and the Trade (in US$) in Russian Federation in 2005?
Your answer should be very brief. -2.64e+11. What is the difference between the Trade (in US$) of Iran in 2003 and the Trade (in US$) of Russian Federation in 2005?
Keep it short and to the point. -2.31e+11. What is the difference between the Trade (in US$) in Pacific island small states in 2004 and the Trade (in US$) in Brunei Darussalam in 2005?
Your answer should be very brief. -4.60e+09. What is the difference between the Trade (in US$) of Pacific island small states in 2004 and the Trade (in US$) of Iran in 2005?
Your answer should be compact. -6.65e+1. What is the difference between the Trade (in US$) of Pacific island small states in 2004 and the Trade (in US$) of Russian Federation in 2005?
Provide a short and direct response. -2.67e+11. What is the difference between the Trade (in US$) of Brunei Darussalam in 2004 and the Trade (in US$) of Iran in 2005?
Make the answer very short. -6.32e+1. What is the difference between the Trade (in US$) of Brunei Darussalam in 2004 and the Trade (in US$) of Russian Federation in 2005?
Offer a very short reply. -2.64e+11. What is the difference between the Trade (in US$) in Iran in 2004 and the Trade (in US$) in Russian Federation in 2005?
Make the answer very short. -2.21e+11. What is the average Trade (in US$) in Pacific island small states per year?
Your response must be concise. 1.75e+09. What is the average Trade (in US$) of Brunei Darussalam per year?
Offer a terse response. 4.14e+09. What is the average Trade (in US$) of Iran per year?
Give a very brief answer. 3.37e+1. What is the average Trade (in US$) in Russian Federation per year?
Give a very brief answer. 1.43e+11. In the year 1998, what is the difference between the Trade (in US$) of Pacific island small states and Trade (in US$) of Brunei Darussalam?
Ensure brevity in your answer.  -5.38e+08. In the year 1998, what is the difference between the Trade (in US$) in Pacific island small states and Trade (in US$) in Iran?
Give a very brief answer. -1.25e+1. In the year 1998, what is the difference between the Trade (in US$) of Pacific island small states and Trade (in US$) of Russian Federation?
Offer a terse response. -8.31e+1. In the year 1998, what is the difference between the Trade (in US$) of Brunei Darussalam and Trade (in US$) of Iran?
Your answer should be very brief. -1.19e+1. In the year 1998, what is the difference between the Trade (in US$) of Brunei Darussalam and Trade (in US$) of Russian Federation?
Your answer should be compact. -8.26e+1. In the year 1998, what is the difference between the Trade (in US$) in Iran and Trade (in US$) in Russian Federation?
Keep it short and to the point. -7.06e+1. In the year 1999, what is the difference between the Trade (in US$) of Pacific island small states and Trade (in US$) of Brunei Darussalam?
Ensure brevity in your answer.  -9.01e+08. In the year 1999, what is the difference between the Trade (in US$) of Pacific island small states and Trade (in US$) of Iran?
Give a very brief answer. -2.03e+1. In the year 1999, what is the difference between the Trade (in US$) of Pacific island small states and Trade (in US$) of Russian Federation?
Make the answer very short. -8.30e+1. In the year 1999, what is the difference between the Trade (in US$) of Brunei Darussalam and Trade (in US$) of Iran?
Offer a terse response. -1.94e+1. In the year 1999, what is the difference between the Trade (in US$) in Brunei Darussalam and Trade (in US$) in Russian Federation?
Provide a succinct answer. -8.21e+1. In the year 1999, what is the difference between the Trade (in US$) of Iran and Trade (in US$) of Russian Federation?
Provide a short and direct response. -6.27e+1. In the year 2000, what is the difference between the Trade (in US$) of Pacific island small states and Trade (in US$) of Brunei Darussalam?
Your response must be concise. -2.48e+09. In the year 2000, what is the difference between the Trade (in US$) in Pacific island small states and Trade (in US$) in Iran?
Your answer should be very brief. -2.20e+1. In the year 2000, what is the difference between the Trade (in US$) of Pacific island small states and Trade (in US$) of Russian Federation?
Provide a succinct answer. -1.13e+11. In the year 2000, what is the difference between the Trade (in US$) in Brunei Darussalam and Trade (in US$) in Iran?
Your response must be concise. -1.95e+1. In the year 2000, what is the difference between the Trade (in US$) of Brunei Darussalam and Trade (in US$) of Russian Federation?
Keep it short and to the point. -1.10e+11. In the year 2000, what is the difference between the Trade (in US$) in Iran and Trade (in US$) in Russian Federation?
Offer a terse response. -9.09e+1. In the year 2001, what is the difference between the Trade (in US$) in Pacific island small states and Trade (in US$) in Brunei Darussalam?
Your response must be concise. -2.47e+09. In the year 2001, what is the difference between the Trade (in US$) of Pacific island small states and Trade (in US$) of Iran?
Make the answer very short. -2.31e+1. In the year 2001, what is the difference between the Trade (in US$) of Pacific island small states and Trade (in US$) of Russian Federation?
Provide a succinct answer. -1.12e+11. In the year 2001, what is the difference between the Trade (in US$) of Brunei Darussalam and Trade (in US$) of Iran?
Offer a terse response. -2.06e+1. In the year 2001, what is the difference between the Trade (in US$) of Brunei Darussalam and Trade (in US$) of Russian Federation?
Your response must be concise. -1.09e+11. In the year 2001, what is the difference between the Trade (in US$) of Iran and Trade (in US$) of Russian Federation?
Your answer should be very brief. -8.86e+1. In the year 2002, what is the difference between the Trade (in US$) in Pacific island small states and Trade (in US$) in Brunei Darussalam?
Provide a succinct answer. -2.33e+09. In the year 2002, what is the difference between the Trade (in US$) in Pacific island small states and Trade (in US$) in Iran?
Make the answer very short. -2.98e+1. In the year 2002, what is the difference between the Trade (in US$) in Pacific island small states and Trade (in US$) in Russian Federation?
Provide a succinct answer. -1.20e+11. In the year 2002, what is the difference between the Trade (in US$) of Brunei Darussalam and Trade (in US$) of Iran?
Your response must be concise. -2.75e+1. In the year 2002, what is the difference between the Trade (in US$) in Brunei Darussalam and Trade (in US$) in Russian Federation?
Your response must be concise. -1.18e+11. In the year 2002, what is the difference between the Trade (in US$) of Iran and Trade (in US$) of Russian Federation?
Provide a succinct answer. -9.02e+1. In the year 2003, what is the difference between the Trade (in US$) of Pacific island small states and Trade (in US$) of Brunei Darussalam?
Your answer should be very brief. -2.64e+09. In the year 2003, what is the difference between the Trade (in US$) of Pacific island small states and Trade (in US$) of Iran?
Make the answer very short. -3.59e+1. In the year 2003, what is the difference between the Trade (in US$) in Pacific island small states and Trade (in US$) in Russian Federation?
Your answer should be compact. -1.50e+11. In the year 2003, what is the difference between the Trade (in US$) in Brunei Darussalam and Trade (in US$) in Iran?
Your response must be concise. -3.33e+1. In the year 2003, what is the difference between the Trade (in US$) of Brunei Darussalam and Trade (in US$) of Russian Federation?
Provide a succinct answer. -1.47e+11. In the year 2003, what is the difference between the Trade (in US$) of Iran and Trade (in US$) of Russian Federation?
Make the answer very short. -1.14e+11. In the year 2004, what is the difference between the Trade (in US$) in Pacific island small states and Trade (in US$) in Brunei Darussalam?
Give a very brief answer. -3.33e+09. In the year 2004, what is the difference between the Trade (in US$) of Pacific island small states and Trade (in US$) of Iran?
Keep it short and to the point. -4.59e+1. In the year 2004, what is the difference between the Trade (in US$) in Pacific island small states and Trade (in US$) in Russian Federation?
Make the answer very short. -2.01e+11. In the year 2004, what is the difference between the Trade (in US$) of Brunei Darussalam and Trade (in US$) of Iran?
Offer a terse response. -4.26e+1. In the year 2004, what is the difference between the Trade (in US$) in Brunei Darussalam and Trade (in US$) in Russian Federation?
Your answer should be compact. -1.98e+11. In the year 2004, what is the difference between the Trade (in US$) of Iran and Trade (in US$) of Russian Federation?
Provide a succinct answer. -1.55e+11. In the year 2005, what is the difference between the Trade (in US$) in Pacific island small states and Trade (in US$) in Brunei Darussalam?
Your answer should be compact. -4.39e+09. In the year 2005, what is the difference between the Trade (in US$) of Pacific island small states and Trade (in US$) of Iran?
Your response must be concise. -6.63e+1. In the year 2005, what is the difference between the Trade (in US$) of Pacific island small states and Trade (in US$) of Russian Federation?
Your answer should be compact. -2.67e+11. In the year 2005, what is the difference between the Trade (in US$) of Brunei Darussalam and Trade (in US$) of Iran?
Keep it short and to the point. -6.19e+1. In the year 2005, what is the difference between the Trade (in US$) in Brunei Darussalam and Trade (in US$) in Russian Federation?
Your answer should be very brief. -2.62e+11. In the year 2005, what is the difference between the Trade (in US$) of Iran and Trade (in US$) of Russian Federation?
Give a very brief answer. -2.00e+11. What is the ratio of the Trade (in US$) of Pacific island small states in 1998 to that in 1999?
Keep it short and to the point. 0.9. What is the ratio of the Trade (in US$) of Brunei Darussalam in 1998 to that in 1999?
Provide a short and direct response. 0.8. What is the ratio of the Trade (in US$) in Iran in 1998 to that in 1999?
Make the answer very short. 0.64. What is the ratio of the Trade (in US$) of Brunei Darussalam in 1998 to that in 2000?
Offer a terse response. 0.51. What is the ratio of the Trade (in US$) in Iran in 1998 to that in 2000?
Keep it short and to the point. 0.59. What is the ratio of the Trade (in US$) in Russian Federation in 1998 to that in 2000?
Keep it short and to the point. 0.74. What is the ratio of the Trade (in US$) of Pacific island small states in 1998 to that in 2001?
Your answer should be very brief. 1.06. What is the ratio of the Trade (in US$) in Brunei Darussalam in 1998 to that in 2001?
Provide a succinct answer. 0.53. What is the ratio of the Trade (in US$) in Iran in 1998 to that in 2001?
Provide a short and direct response. 0.57. What is the ratio of the Trade (in US$) of Russian Federation in 1998 to that in 2001?
Offer a very short reply. 0.75. What is the ratio of the Trade (in US$) of Pacific island small states in 1998 to that in 2002?
Your response must be concise. 0.95. What is the ratio of the Trade (in US$) in Brunei Darussalam in 1998 to that in 2002?
Ensure brevity in your answer.  0.52. What is the ratio of the Trade (in US$) in Iran in 1998 to that in 2002?
Make the answer very short. 0.45. What is the ratio of the Trade (in US$) of Russian Federation in 1998 to that in 2002?
Your answer should be very brief. 0.7. What is the ratio of the Trade (in US$) in Pacific island small states in 1998 to that in 2003?
Offer a very short reply. 0.79. What is the ratio of the Trade (in US$) in Brunei Darussalam in 1998 to that in 2003?
Provide a succinct answer. 0.45. What is the ratio of the Trade (in US$) in Iran in 1998 to that in 2003?
Offer a very short reply. 0.37. What is the ratio of the Trade (in US$) in Russian Federation in 1998 to that in 2003?
Your answer should be compact. 0.56. What is the ratio of the Trade (in US$) of Pacific island small states in 1998 to that in 2004?
Offer a terse response. 0.72. What is the ratio of the Trade (in US$) in Brunei Darussalam in 1998 to that in 2004?
Ensure brevity in your answer.  0.38. What is the ratio of the Trade (in US$) in Iran in 1998 to that in 2004?
Make the answer very short. 0.29. What is the ratio of the Trade (in US$) of Russian Federation in 1998 to that in 2004?
Keep it short and to the point. 0.42. What is the ratio of the Trade (in US$) in Pacific island small states in 1998 to that in 2005?
Provide a succinct answer. 0.66. What is the ratio of the Trade (in US$) of Brunei Darussalam in 1998 to that in 2005?
Keep it short and to the point. 0.31. What is the ratio of the Trade (in US$) in Iran in 1998 to that in 2005?
Give a very brief answer. 0.2. What is the ratio of the Trade (in US$) in Russian Federation in 1998 to that in 2005?
Offer a very short reply. 0.31. What is the ratio of the Trade (in US$) in Pacific island small states in 1999 to that in 2000?
Give a very brief answer. 1.07. What is the ratio of the Trade (in US$) in Brunei Darussalam in 1999 to that in 2000?
Your response must be concise. 0.64. What is the ratio of the Trade (in US$) in Iran in 1999 to that in 2000?
Offer a very short reply. 0.93. What is the ratio of the Trade (in US$) of Russian Federation in 1999 to that in 2000?
Your answer should be compact. 0.74. What is the ratio of the Trade (in US$) in Pacific island small states in 1999 to that in 2001?
Provide a short and direct response. 1.17. What is the ratio of the Trade (in US$) of Brunei Darussalam in 1999 to that in 2001?
Your response must be concise. 0.66. What is the ratio of the Trade (in US$) of Iran in 1999 to that in 2001?
Your answer should be very brief. 0.9. What is the ratio of the Trade (in US$) of Russian Federation in 1999 to that in 2001?
Your answer should be very brief. 0.75. What is the ratio of the Trade (in US$) in Pacific island small states in 1999 to that in 2002?
Ensure brevity in your answer.  1.05. What is the ratio of the Trade (in US$) of Brunei Darussalam in 1999 to that in 2002?
Your response must be concise. 0.65. What is the ratio of the Trade (in US$) in Iran in 1999 to that in 2002?
Your answer should be compact. 0.7. What is the ratio of the Trade (in US$) of Russian Federation in 1999 to that in 2002?
Your response must be concise. 0.7. What is the ratio of the Trade (in US$) of Pacific island small states in 1999 to that in 2003?
Your answer should be very brief. 0.87. What is the ratio of the Trade (in US$) in Brunei Darussalam in 1999 to that in 2003?
Ensure brevity in your answer.  0.57. What is the ratio of the Trade (in US$) in Iran in 1999 to that in 2003?
Ensure brevity in your answer.  0.58. What is the ratio of the Trade (in US$) of Russian Federation in 1999 to that in 2003?
Make the answer very short. 0.56. What is the ratio of the Trade (in US$) of Pacific island small states in 1999 to that in 2004?
Ensure brevity in your answer.  0.8. What is the ratio of the Trade (in US$) of Brunei Darussalam in 1999 to that in 2004?
Offer a terse response. 0.47. What is the ratio of the Trade (in US$) of Iran in 1999 to that in 2004?
Make the answer very short. 0.46. What is the ratio of the Trade (in US$) of Russian Federation in 1999 to that in 2004?
Keep it short and to the point. 0.42. What is the ratio of the Trade (in US$) of Pacific island small states in 1999 to that in 2005?
Ensure brevity in your answer.  0.73. What is the ratio of the Trade (in US$) in Brunei Darussalam in 1999 to that in 2005?
Make the answer very short. 0.38. What is the ratio of the Trade (in US$) in Iran in 1999 to that in 2005?
Make the answer very short. 0.32. What is the ratio of the Trade (in US$) of Russian Federation in 1999 to that in 2005?
Your response must be concise. 0.31. What is the ratio of the Trade (in US$) of Pacific island small states in 2000 to that in 2001?
Your answer should be compact. 1.1. What is the ratio of the Trade (in US$) of Brunei Darussalam in 2000 to that in 2001?
Offer a terse response. 1.04. What is the ratio of the Trade (in US$) of Iran in 2000 to that in 2001?
Your answer should be compact. 0.96. What is the ratio of the Trade (in US$) of Russian Federation in 2000 to that in 2001?
Your response must be concise. 1.01. What is the ratio of the Trade (in US$) of Pacific island small states in 2000 to that in 2002?
Your answer should be very brief. 0.98. What is the ratio of the Trade (in US$) in Brunei Darussalam in 2000 to that in 2002?
Make the answer very short. 1.03. What is the ratio of the Trade (in US$) in Iran in 2000 to that in 2002?
Your answer should be very brief. 0.75. What is the ratio of the Trade (in US$) in Russian Federation in 2000 to that in 2002?
Your answer should be compact. 0.94. What is the ratio of the Trade (in US$) in Pacific island small states in 2000 to that in 2003?
Offer a very short reply. 0.82. What is the ratio of the Trade (in US$) of Brunei Darussalam in 2000 to that in 2003?
Give a very brief answer. 0.89. What is the ratio of the Trade (in US$) of Iran in 2000 to that in 2003?
Keep it short and to the point. 0.62. What is the ratio of the Trade (in US$) of Russian Federation in 2000 to that in 2003?
Your answer should be compact. 0.75. What is the ratio of the Trade (in US$) in Pacific island small states in 2000 to that in 2004?
Give a very brief answer. 0.75. What is the ratio of the Trade (in US$) of Brunei Darussalam in 2000 to that in 2004?
Your answer should be very brief. 0.75. What is the ratio of the Trade (in US$) in Iran in 2000 to that in 2004?
Your response must be concise. 0.49. What is the ratio of the Trade (in US$) in Russian Federation in 2000 to that in 2004?
Your answer should be very brief. 0.56. What is the ratio of the Trade (in US$) of Pacific island small states in 2000 to that in 2005?
Give a very brief answer. 0.68. What is the ratio of the Trade (in US$) of Brunei Darussalam in 2000 to that in 2005?
Make the answer very short. 0.6. What is the ratio of the Trade (in US$) in Iran in 2000 to that in 2005?
Offer a very short reply. 0.34. What is the ratio of the Trade (in US$) in Russian Federation in 2000 to that in 2005?
Make the answer very short. 0.43. What is the ratio of the Trade (in US$) in Pacific island small states in 2001 to that in 2002?
Provide a short and direct response. 0.89. What is the ratio of the Trade (in US$) of Iran in 2001 to that in 2002?
Your response must be concise. 0.78. What is the ratio of the Trade (in US$) in Russian Federation in 2001 to that in 2002?
Provide a short and direct response. 0.93. What is the ratio of the Trade (in US$) of Pacific island small states in 2001 to that in 2003?
Your answer should be compact. 0.74. What is the ratio of the Trade (in US$) in Iran in 2001 to that in 2003?
Make the answer very short. 0.65. What is the ratio of the Trade (in US$) of Russian Federation in 2001 to that in 2003?
Provide a short and direct response. 0.75. What is the ratio of the Trade (in US$) of Pacific island small states in 2001 to that in 2004?
Ensure brevity in your answer.  0.68. What is the ratio of the Trade (in US$) of Brunei Darussalam in 2001 to that in 2004?
Keep it short and to the point. 0.72. What is the ratio of the Trade (in US$) in Iran in 2001 to that in 2004?
Give a very brief answer. 0.51. What is the ratio of the Trade (in US$) of Russian Federation in 2001 to that in 2004?
Ensure brevity in your answer.  0.56. What is the ratio of the Trade (in US$) of Pacific island small states in 2001 to that in 2005?
Provide a short and direct response. 0.62. What is the ratio of the Trade (in US$) of Brunei Darussalam in 2001 to that in 2005?
Your answer should be very brief. 0.58. What is the ratio of the Trade (in US$) in Iran in 2001 to that in 2005?
Give a very brief answer. 0.36. What is the ratio of the Trade (in US$) of Russian Federation in 2001 to that in 2005?
Provide a short and direct response. 0.42. What is the ratio of the Trade (in US$) in Pacific island small states in 2002 to that in 2003?
Provide a succinct answer. 0.83. What is the ratio of the Trade (in US$) of Brunei Darussalam in 2002 to that in 2003?
Ensure brevity in your answer.  0.86. What is the ratio of the Trade (in US$) in Iran in 2002 to that in 2003?
Offer a very short reply. 0.83. What is the ratio of the Trade (in US$) of Russian Federation in 2002 to that in 2003?
Your answer should be compact. 0.8. What is the ratio of the Trade (in US$) in Pacific island small states in 2002 to that in 2004?
Ensure brevity in your answer.  0.76. What is the ratio of the Trade (in US$) in Brunei Darussalam in 2002 to that in 2004?
Give a very brief answer. 0.72. What is the ratio of the Trade (in US$) in Iran in 2002 to that in 2004?
Make the answer very short. 0.65. What is the ratio of the Trade (in US$) of Russian Federation in 2002 to that in 2004?
Your answer should be compact. 0.6. What is the ratio of the Trade (in US$) of Pacific island small states in 2002 to that in 2005?
Your answer should be compact. 0.69. What is the ratio of the Trade (in US$) in Brunei Darussalam in 2002 to that in 2005?
Your answer should be very brief. 0.59. What is the ratio of the Trade (in US$) in Iran in 2002 to that in 2005?
Make the answer very short. 0.46. What is the ratio of the Trade (in US$) of Russian Federation in 2002 to that in 2005?
Offer a very short reply. 0.45. What is the ratio of the Trade (in US$) of Pacific island small states in 2003 to that in 2004?
Your answer should be very brief. 0.91. What is the ratio of the Trade (in US$) in Brunei Darussalam in 2003 to that in 2004?
Your response must be concise. 0.84. What is the ratio of the Trade (in US$) in Iran in 2003 to that in 2004?
Provide a short and direct response. 0.79. What is the ratio of the Trade (in US$) in Russian Federation in 2003 to that in 2004?
Your answer should be very brief. 0.75. What is the ratio of the Trade (in US$) in Pacific island small states in 2003 to that in 2005?
Make the answer very short. 0.83. What is the ratio of the Trade (in US$) in Brunei Darussalam in 2003 to that in 2005?
Give a very brief answer. 0.68. What is the ratio of the Trade (in US$) of Iran in 2003 to that in 2005?
Give a very brief answer. 0.55. What is the ratio of the Trade (in US$) of Russian Federation in 2003 to that in 2005?
Make the answer very short. 0.56. What is the ratio of the Trade (in US$) of Pacific island small states in 2004 to that in 2005?
Your response must be concise. 0.91. What is the ratio of the Trade (in US$) of Brunei Darussalam in 2004 to that in 2005?
Your answer should be very brief. 0.81. What is the ratio of the Trade (in US$) of Iran in 2004 to that in 2005?
Keep it short and to the point. 0.7. What is the ratio of the Trade (in US$) in Russian Federation in 2004 to that in 2005?
Make the answer very short. 0.76. What is the difference between the highest and the second highest Trade (in US$) of Pacific island small states?
Ensure brevity in your answer.  2.05e+08. What is the difference between the highest and the second highest Trade (in US$) of Brunei Darussalam?
Offer a terse response. 1.27e+09. What is the difference between the highest and the second highest Trade (in US$) of Iran?
Offer a very short reply. 2.06e+1. What is the difference between the highest and the second highest Trade (in US$) of Russian Federation?
Ensure brevity in your answer.  6.55e+1. What is the difference between the highest and the lowest Trade (in US$) of Pacific island small states?
Make the answer very short. 8.75e+08. What is the difference between the highest and the lowest Trade (in US$) in Brunei Darussalam?
Keep it short and to the point. 4.64e+09. What is the difference between the highest and the lowest Trade (in US$) of Iran?
Give a very brief answer. 5.46e+1. What is the difference between the highest and the lowest Trade (in US$) in Russian Federation?
Give a very brief answer. 1.84e+11. 